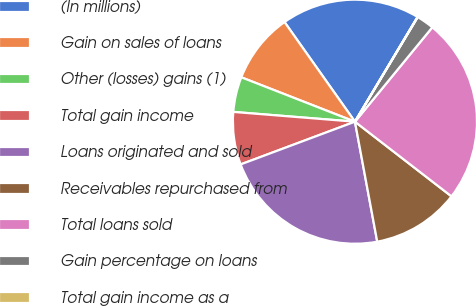<chart> <loc_0><loc_0><loc_500><loc_500><pie_chart><fcel>(In millions)<fcel>Gain on sales of loans<fcel>Other (losses) gains (1)<fcel>Total gain income<fcel>Loans originated and sold<fcel>Receivables repurchased from<fcel>Total loans sold<fcel>Gain percentage on loans<fcel>Total gain income as a<nl><fcel>18.37%<fcel>9.28%<fcel>4.65%<fcel>6.97%<fcel>22.23%<fcel>11.6%<fcel>24.55%<fcel>2.33%<fcel>0.02%<nl></chart> 